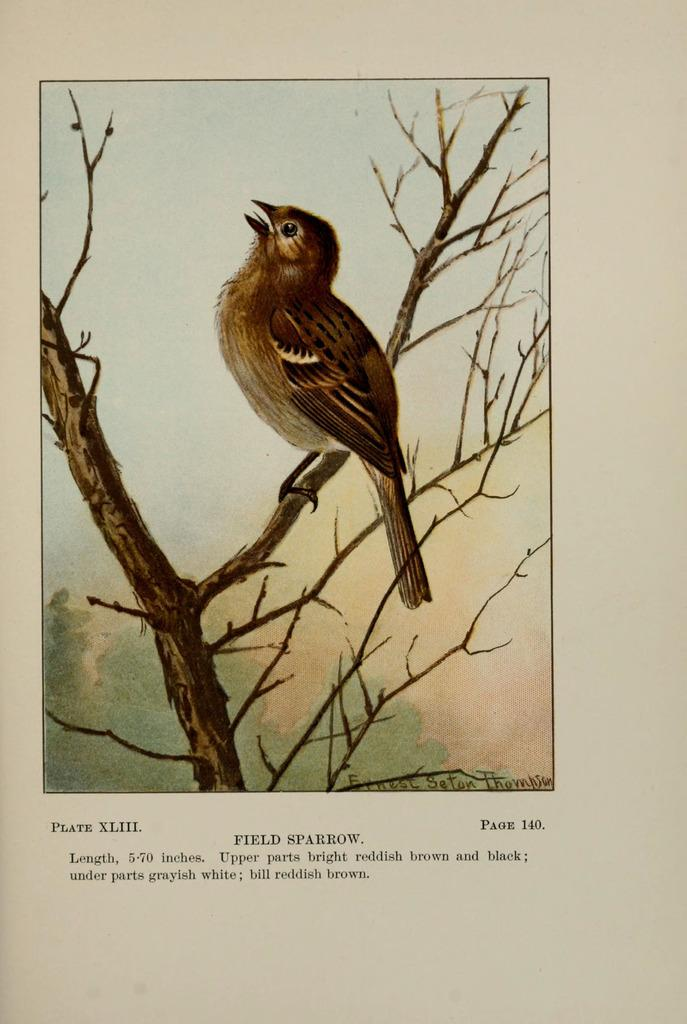What type of animal can be seen in the image? There is a bird in the image. Where is the bird located? The bird is sitting on a branch. Is there any text in the image? Yes, text is present at the bottom of the image. What type of line can be seen connecting the bird to the branch in the image? There is no line connecting the bird to the branch in the image. 